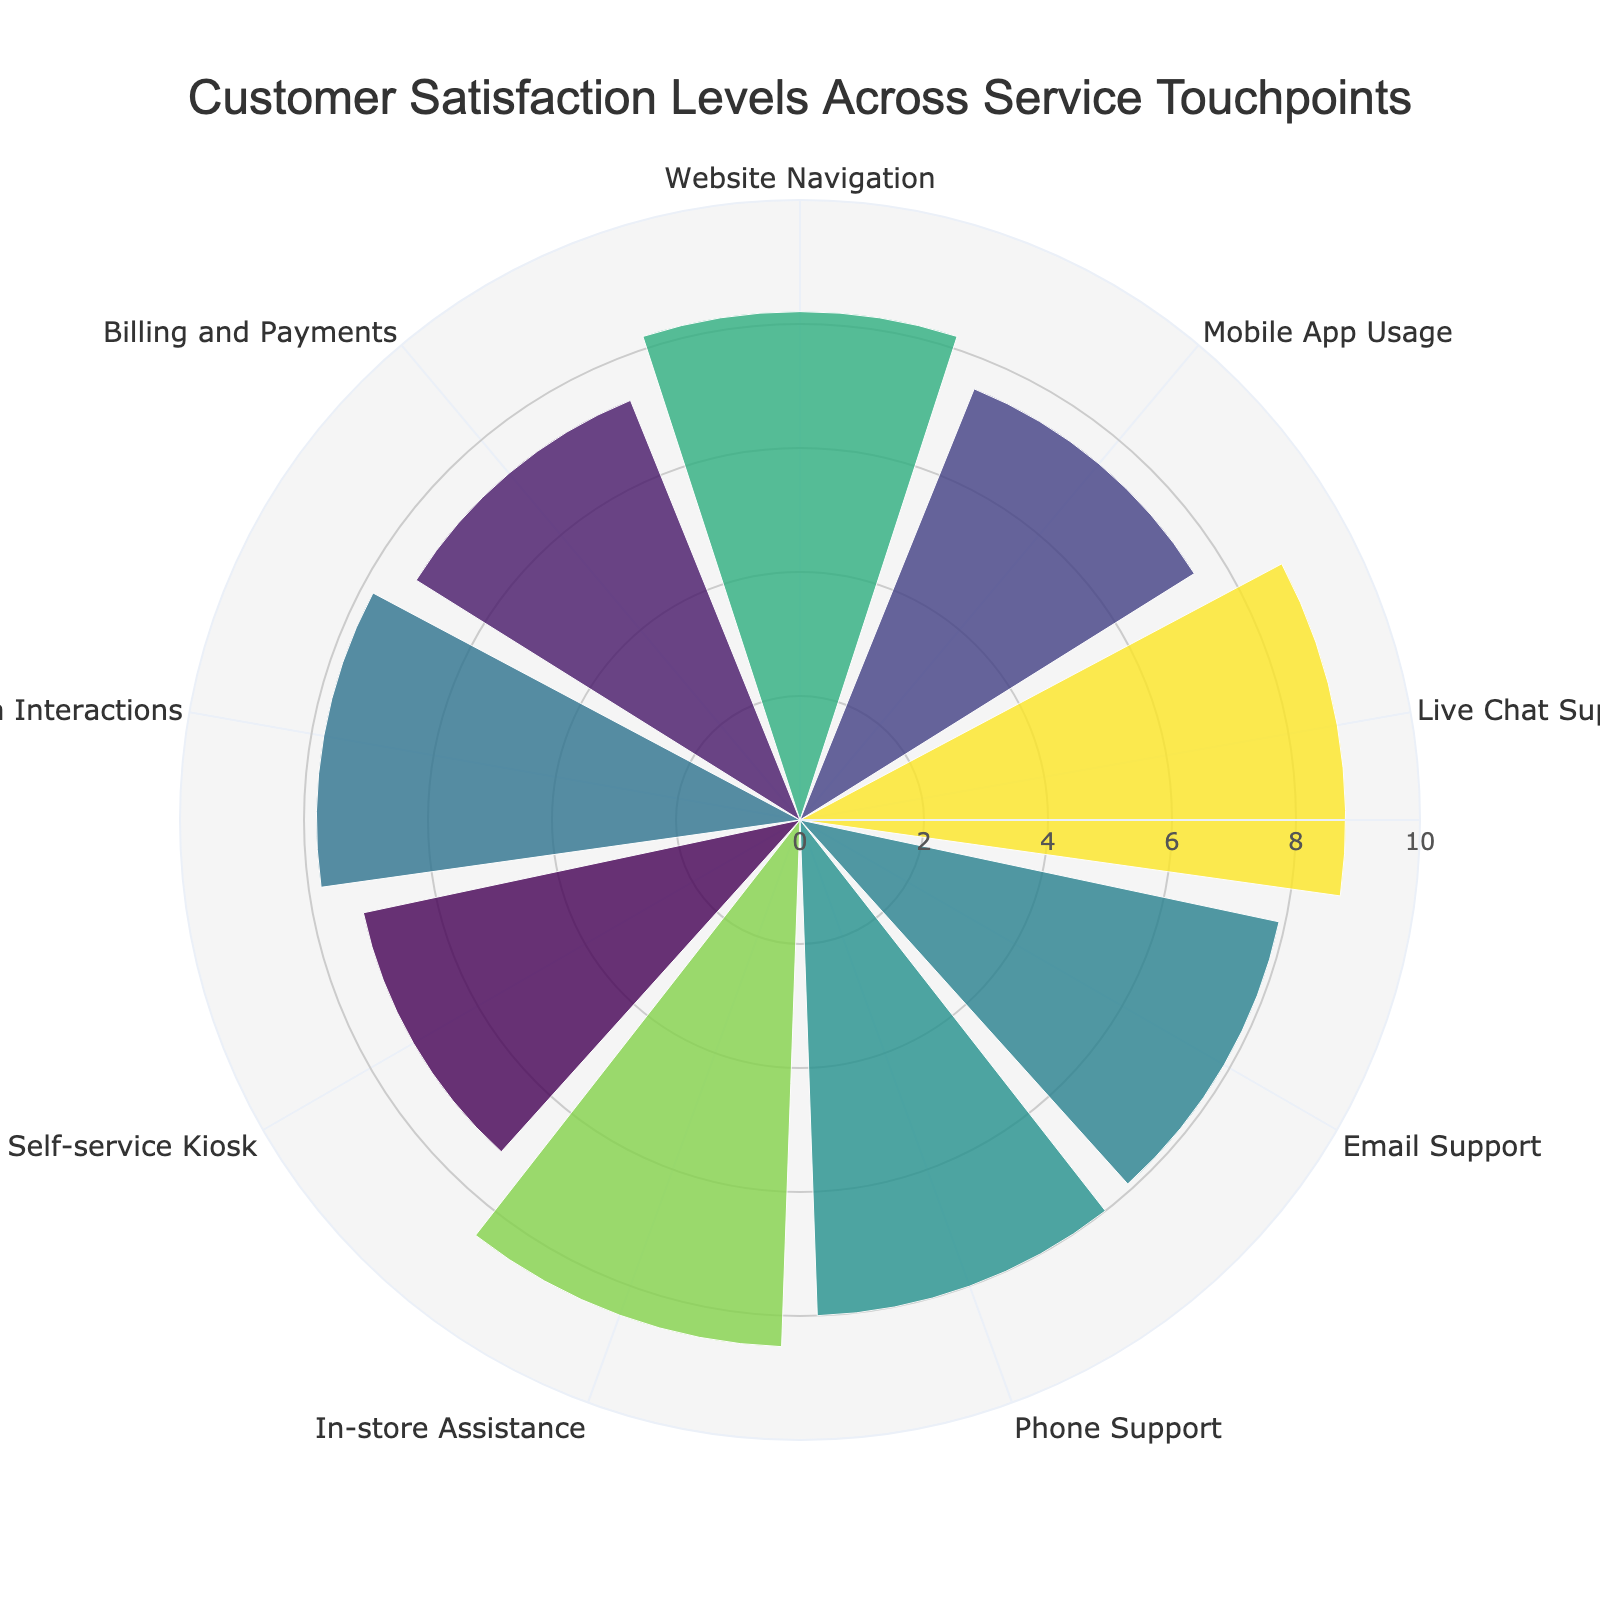What is the title of the polar area chart? The title is typically the most prominent text at the top of the chart. In this case, it states "Customer Satisfaction Levels Across Service Touchpoints."
Answer: Customer Satisfaction Levels Across Service Touchpoints How many service touchpoints are shown in the chart? Count the number of distinct labels around the circle representing different service touchpoints. Each bar in the polar area chart represents a service touchpoint.
Answer: 9 Which service touchpoint has the highest customer satisfaction level? Look for the bar that extends the farthest from the center and check its label. The hovertext might be useful here as it usually shows the exact satisfaction level.
Answer: Live Chat Support What is the satisfaction level for Mobile App Usage? Find the bar labeled "Mobile App Usage" and read the value associated with it, which can be obtained from the hovertext.
Answer: 7.5 Which service touchpoint has the lowest customer satisfaction level? Identify the bar that extends the least from the center and check its label using hovertext if needed.
Answer: Self-service Kiosk By how much does the satisfaction level of In-store Assistance exceed that of Billing and Payments? Subtract the satisfaction level of Billing and Payments from that of In-store Assistance. In-store Assistance: 8.5, Billing and Payments: 7.3. So, 8.5 - 7.3 = 1.2.
Answer: 1.2 What is the average satisfaction level across all service touchpoints? Sum all the satisfaction levels and divide by the number of touchpoints, (8.2 + 7.5 + 8.8 + 7.9 + 8.0 + 8.5 + 7.2 + 7.8 + 7.3)/9 = 7.91.
Answer: 7.91 Which service touchpoints have a satisfaction level greater than 8? Identify the bars extending beyond the 8-mark on the chart. Those labeled "In-store Assistance," "Live Chat Support," "Website Navigation," and "Phone Support" satisfy this condition.
Answer: In-store Assistance, Live Chat Support, Website Navigation, Phone Support What is the difference in satisfaction levels between Live Chat Support and Email Support? Subtract the satisfaction level of Email Support from that of Live Chat Support. Live Chat Support: 8.8, Email Support: 7.9. So, 8.8 - 7.9 = 0.9.
Answer: 0.9 How does the satisfaction level of Social Media Interactions compare to that of Website Navigation? Compare the values directly. Social Media Interactions has a satisfaction level of 7.8, whereas Website Navigation has 8.2. Therefore, Website Navigation has a higher satisfaction level.
Answer: Website Navigation is higher 